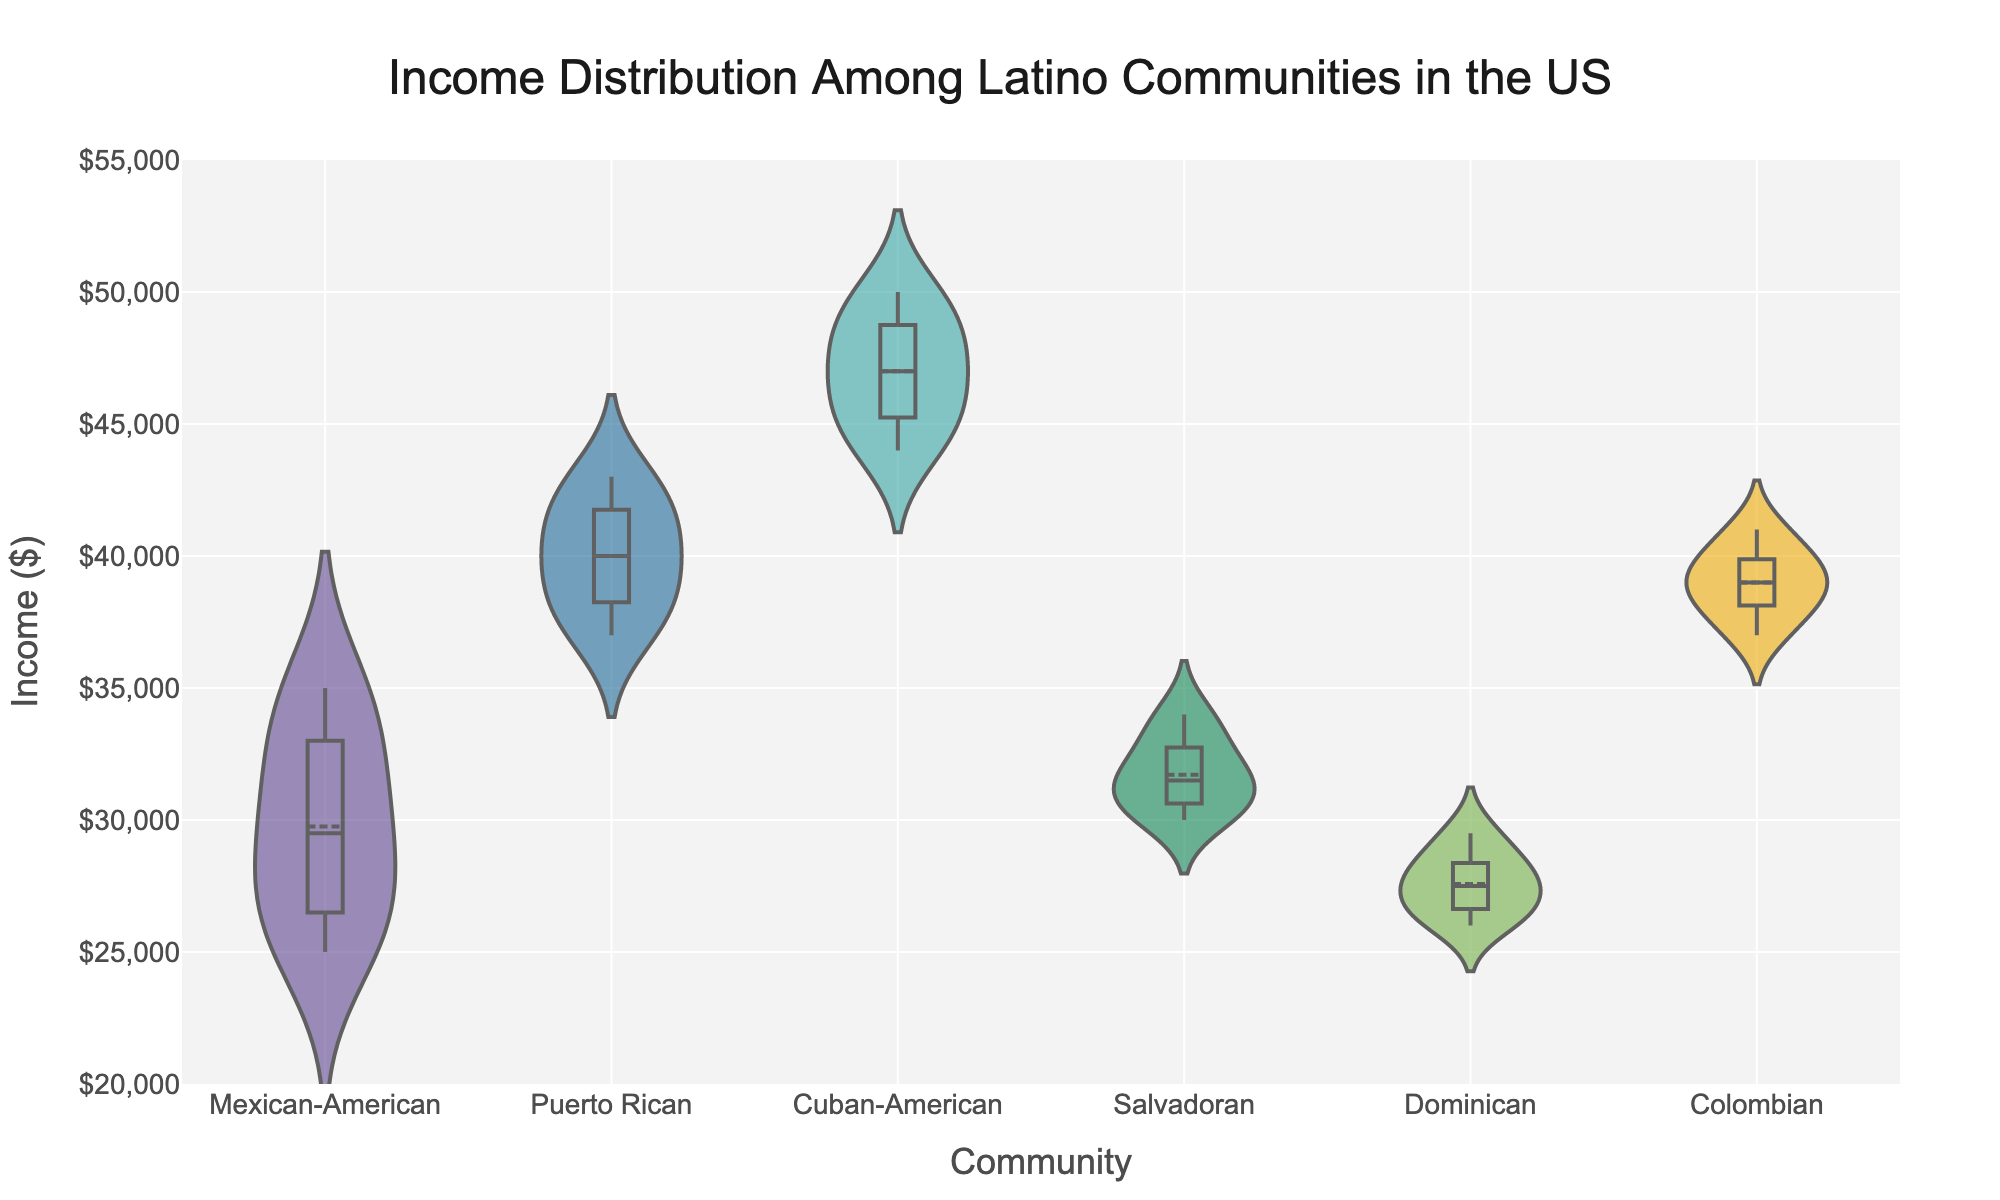What is the title of the figure? The title of the figure is located at the top of the plot and provides context for what the figure is about. In this case, the title is "Income Distribution Among Latino Communities in the US."
Answer: Income Distribution Among Latino Communities in the US What does the x-axis represent? The x-axis of the figure is labeled and indicates what is being measured along this axis. Here, it represents the different Latino communities being analyzed.
Answer: Community What is the income range displayed on the y-axis? The y-axis of the figure shows the range of income values for each community. The range starts at $20,000 and goes up to $55,000, as indicated by the tick marks and axis label.
Answer: $20,000 to $55,000 Which community has the highest median income? To find the highest median income, look at the lines inside the boxes in the violin plots. The Cuban-American community shows the highest median income compared to other communities.
Answer: Cuban-American Which community shows the widest distribution of incomes? The width of the violin plots indicates the distribution of incomes for each community. The Mexican-American community has the widest distribution, as it spans the largest range of income values.
Answer: Mexican-American What is the median income for the Puerto Rican community? The median is indicated by the horizontal line within the box of the violin plot for the Puerto Rican community. The median income is about $40,000.
Answer: $40,000 Compare the median incomes of the Mexican-American and Dominican communities. Which is higher? The median income is shown by the horizontal line within each box of their respective violin plots. The Mexican-American community has a higher median income than the Dominican community.
Answer: Mexican-American What is the general shape of the income distribution for the Colombian community? The shape of the violin plot for the Colombian community will give insight into its income distribution. The distribution seems relatively symmetrical with a concentration around the median, indicating a balanced distribution of incomes.
Answer: Symmetrical and balanced Which community has the lowest lower quartile income? The lower quartile is the bottom of the box in the box plot overlay. The Dominican community has the lowest lower quartile income among all communities.
Answer: Dominican How do the distributions of the Cuban-American and Salvadoran communities compare in terms of range and variance? The range can be determined by the span of the violin plot from the minimum to maximum points, and variance can be inferred from the width. The Cuban-American community has a higher range and likely a higher variance compared to the Salvadoran community.
Answer: Cuban-American has higher range and variance 